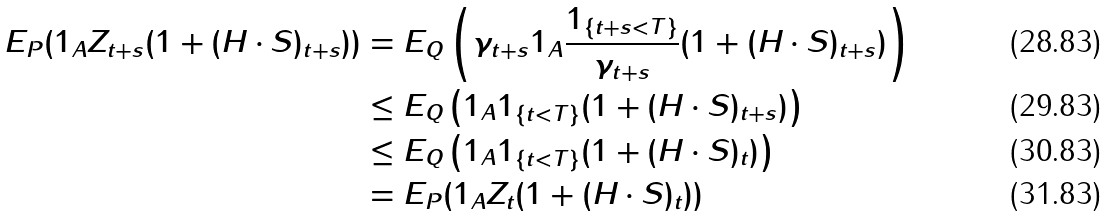<formula> <loc_0><loc_0><loc_500><loc_500>E _ { P } ( 1 _ { A } Z _ { t + s } ( 1 + ( H \cdot S ) _ { t + s } ) ) & = E _ { Q } \left ( \gamma _ { t + s } 1 _ { A } \frac { 1 _ { \{ t + s < T \} } } { \gamma _ { t + s } } ( 1 + ( H \cdot S ) _ { t + s } ) \right ) \\ & \leq E _ { Q } \left ( 1 _ { A } 1 _ { \{ t < T \} } ( 1 + ( H \cdot S ) _ { t + s } ) \right ) \\ & \leq E _ { Q } \left ( 1 _ { A } 1 _ { \{ t < T \} } ( 1 + ( H \cdot S ) _ { t } ) \right ) \\ & = E _ { P } ( 1 _ { A } Z _ { t } ( 1 + ( H \cdot S ) _ { t } ) )</formula> 